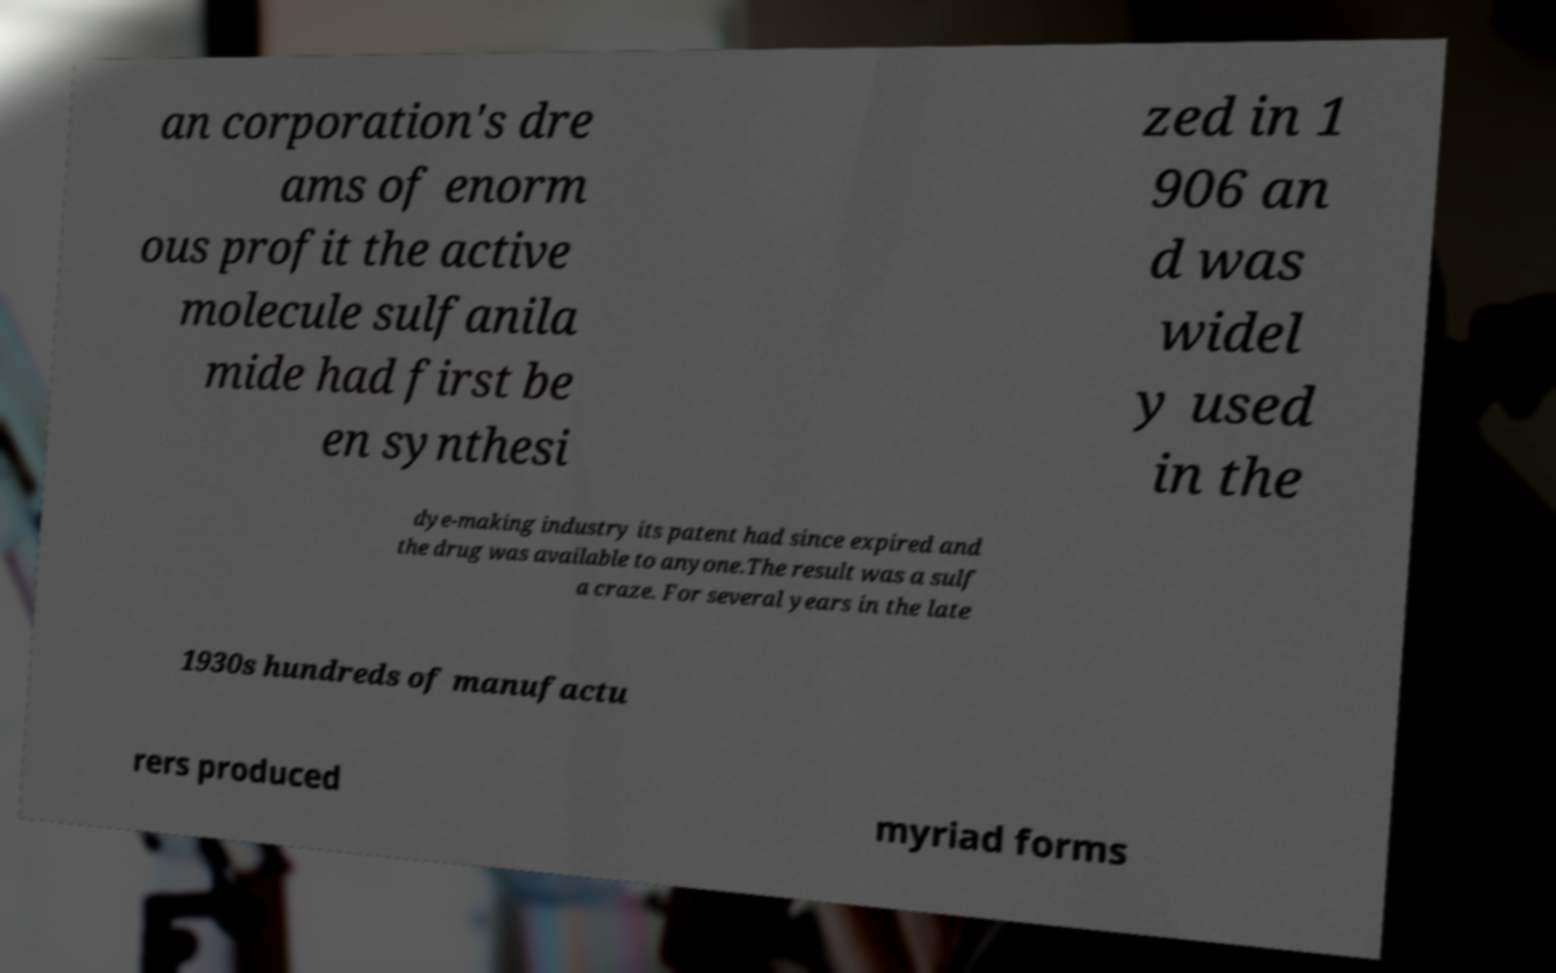Can you accurately transcribe the text from the provided image for me? an corporation's dre ams of enorm ous profit the active molecule sulfanila mide had first be en synthesi zed in 1 906 an d was widel y used in the dye-making industry its patent had since expired and the drug was available to anyone.The result was a sulf a craze. For several years in the late 1930s hundreds of manufactu rers produced myriad forms 